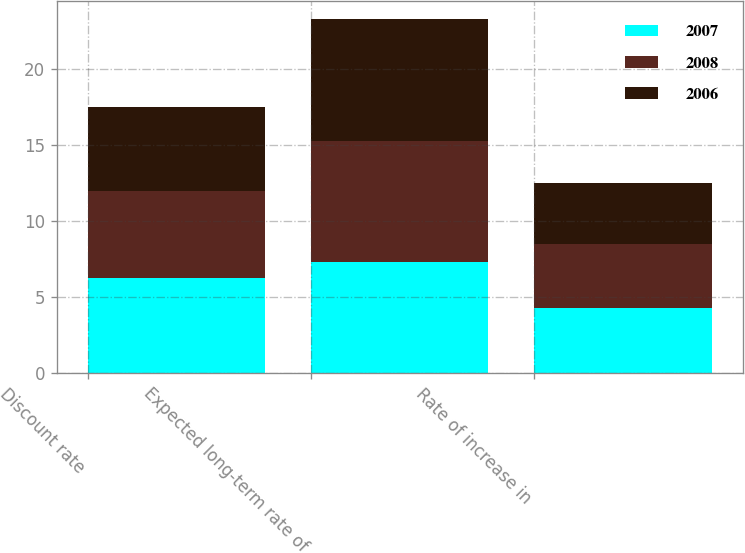Convert chart. <chart><loc_0><loc_0><loc_500><loc_500><stacked_bar_chart><ecel><fcel>Discount rate<fcel>Expected long-term rate of<fcel>Rate of increase in<nl><fcel>2007<fcel>6.25<fcel>7.3<fcel>4.25<nl><fcel>2008<fcel>5.75<fcel>8<fcel>4.25<nl><fcel>2006<fcel>5.5<fcel>8<fcel>4<nl></chart> 